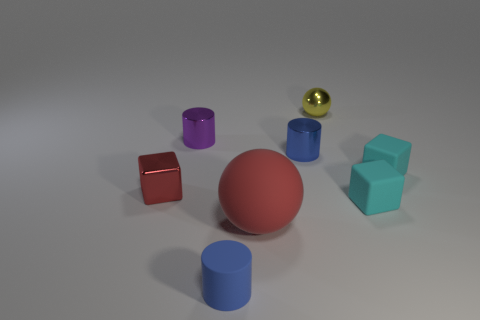Subtract all matte blocks. How many blocks are left? 1 Add 2 red metal cubes. How many objects exist? 10 Subtract all blue cylinders. How many cylinders are left? 1 Subtract all gray cubes. How many blue cylinders are left? 2 Add 6 small cyan things. How many small cyan things exist? 8 Subtract 2 cyan cubes. How many objects are left? 6 Subtract all balls. How many objects are left? 6 Subtract 3 cylinders. How many cylinders are left? 0 Subtract all cyan cubes. Subtract all green spheres. How many cubes are left? 1 Subtract all tiny rubber balls. Subtract all small red blocks. How many objects are left? 7 